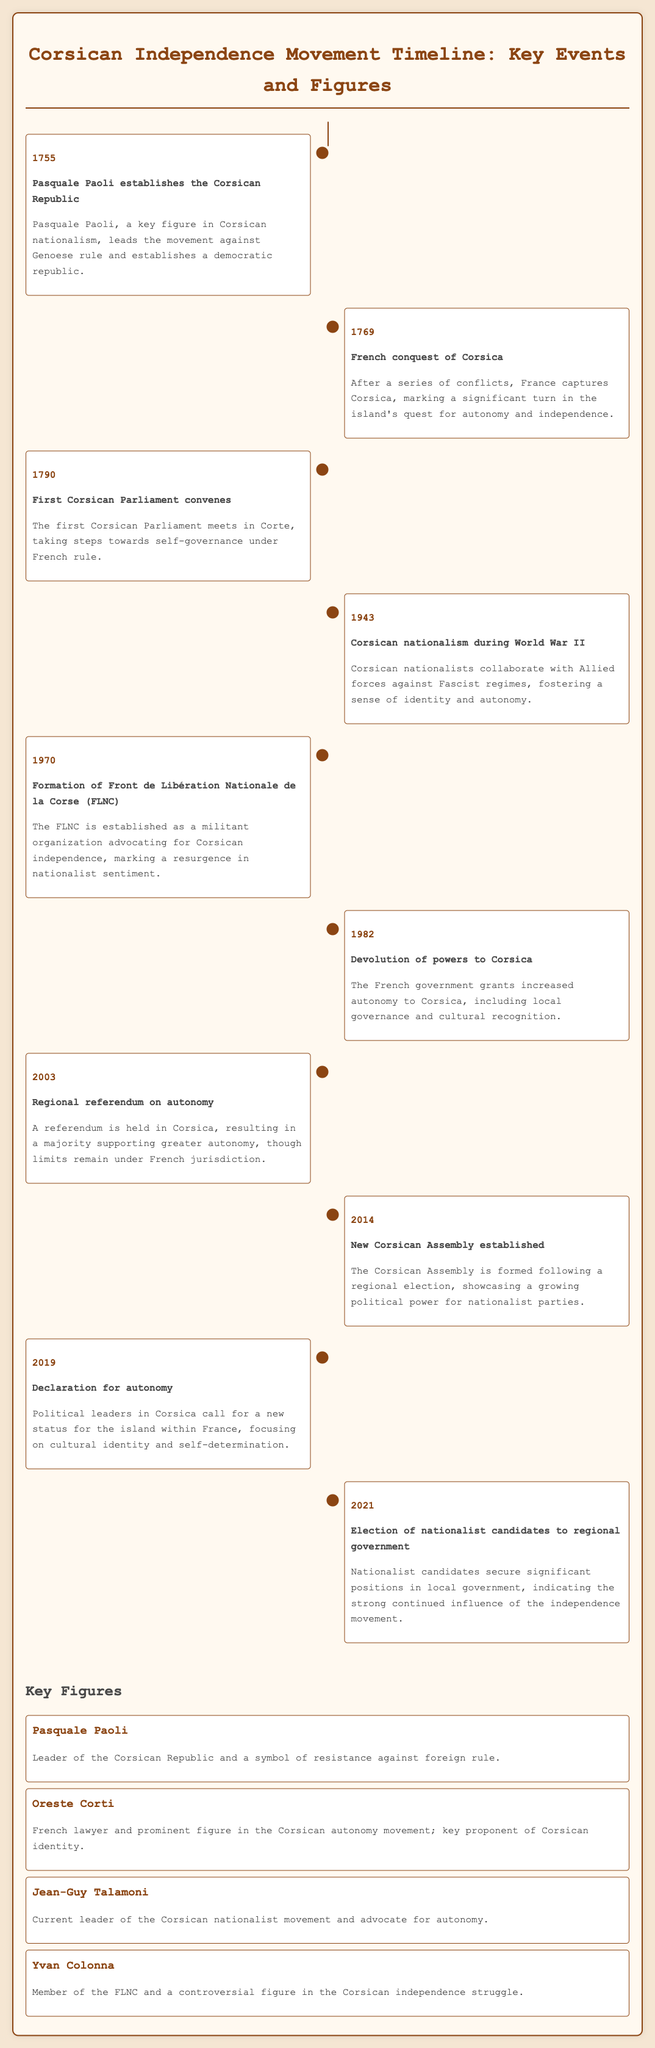What year was the Corsican Republic established? The year of the establishment of the Corsican Republic is explicitly stated in the document.
Answer: 1755 Who established the Corsican Republic? The document specifies Pasquale Paoli as the individual who established the Corsican Republic.
Answer: Pasquale Paoli What significant event occurred in 1769? The document notes that in 1769, France conquered Corsica, marking a significant turn in its history.
Answer: French conquest of Corsica Which organization was formed in 1970? The formation of a specific organization in 1970 is detailed in the document.
Answer: Front de Libération Nationale de la Corse (FLNC) What does the 2003 referendum pertain to? The document mentions that the 2003 referendum was held regarding Corsican autonomy.
Answer: Autonomy What was the role of Corsican nationalists during World War II? The document outlines that Corsican nationalists collaborated with Allied forces during World War II.
Answer: Collaborate with Allied forces Which figure is described as the current leader of the Corsican nationalist movement? The document provides information on a key figure currently leading the movement.
Answer: Jean-Guy Talamoni What was granted to Corsica in 1982? The document states that the French government granted certain powers to Corsica in 1982.
Answer: Increased autonomy What is the purpose of the Corsican Assembly established in 2014? The document explains the significance of the newly formed Corsican Assembly following a regional election.
Answer: Showcase growing political power What year did Corsican nationalists declare for autonomy? The year of the political leaders' declaration for autonomy is stated in the document.
Answer: 2019 